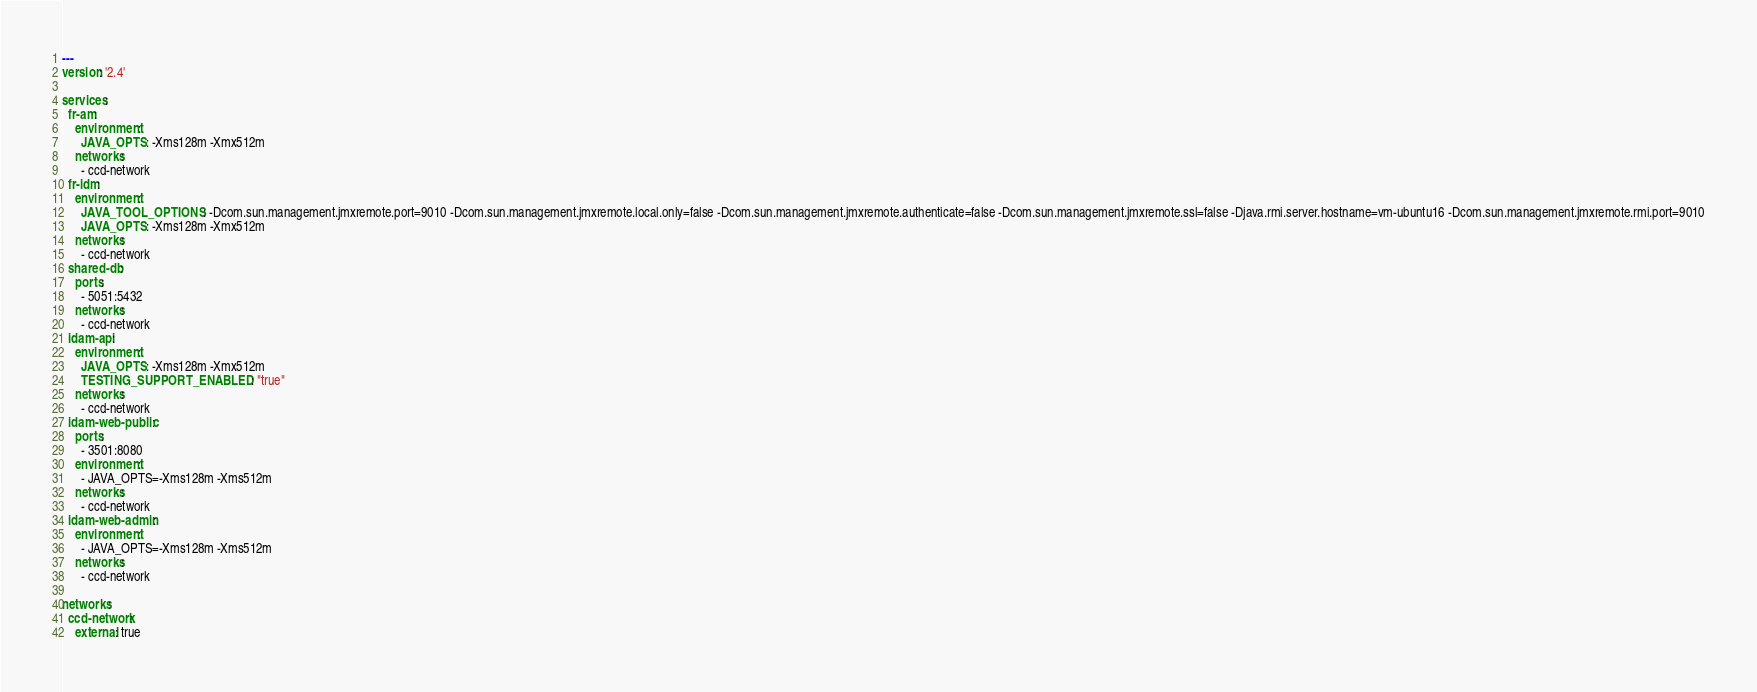<code> <loc_0><loc_0><loc_500><loc_500><_YAML_>---
version: '2.4'

services:
  fr-am:
    environment:
      JAVA_OPTS: -Xms128m -Xmx512m
    networks:
      - ccd-network
  fr-idm:
    environment:
      JAVA_TOOL_OPTIONS: -Dcom.sun.management.jmxremote.port=9010 -Dcom.sun.management.jmxremote.local.only=false -Dcom.sun.management.jmxremote.authenticate=false -Dcom.sun.management.jmxremote.ssl=false -Djava.rmi.server.hostname=vm-ubuntu16 -Dcom.sun.management.jmxremote.rmi.port=9010
      JAVA_OPTS: -Xms128m -Xmx512m
    networks:
      - ccd-network
  shared-db:
    ports:
      - 5051:5432
    networks:
      - ccd-network
  idam-api:
    environment:
      JAVA_OPTS: -Xms128m -Xmx512m
      TESTING_SUPPORT_ENABLED: "true"
    networks:
      - ccd-network
  idam-web-public:
    ports:
      - 3501:8080
    environment:
      - JAVA_OPTS=-Xms128m -Xms512m
    networks:
      - ccd-network
  idam-web-admin:
    environment:
      - JAVA_OPTS=-Xms128m -Xms512m
    networks:
      - ccd-network

networks:
  ccd-network:
    external: true
</code> 